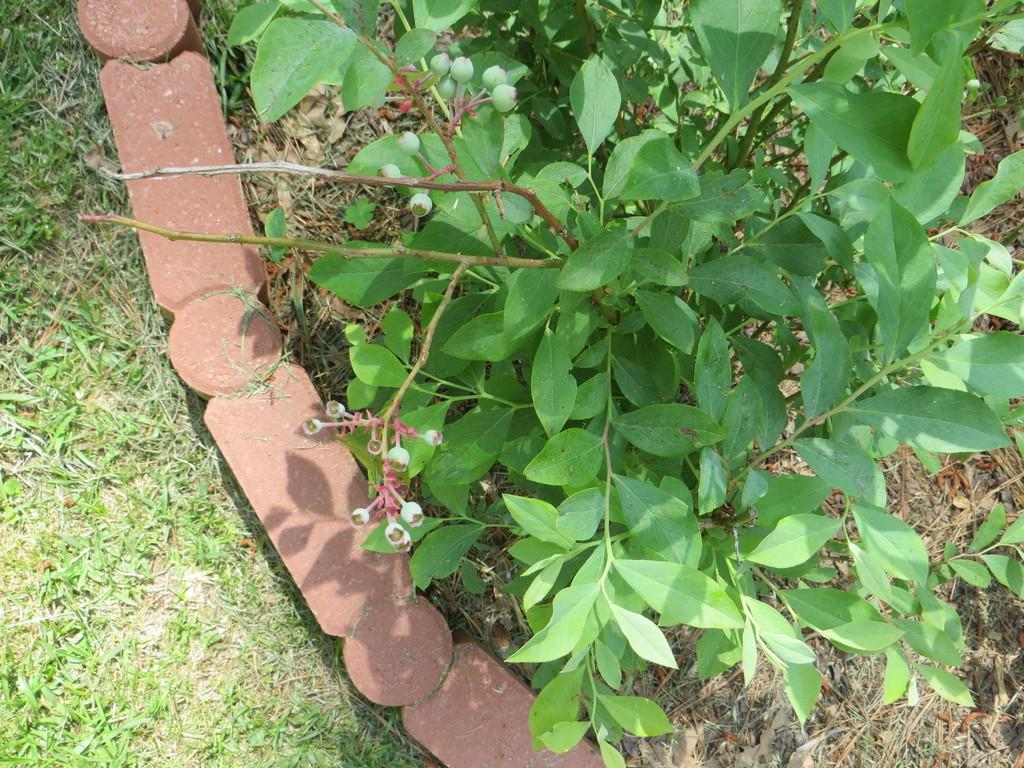What is the main subject of the image? The main subject of the image is a plant. Where is the plant located? The plant is on the grass ground. What else can be seen on the left side of the image? There are brown-colored stones on the left side of the image. What rule is being enforced by the plant in the image? There is no rule being enforced by the plant in the image, as plants do not have the ability to enforce rules. 